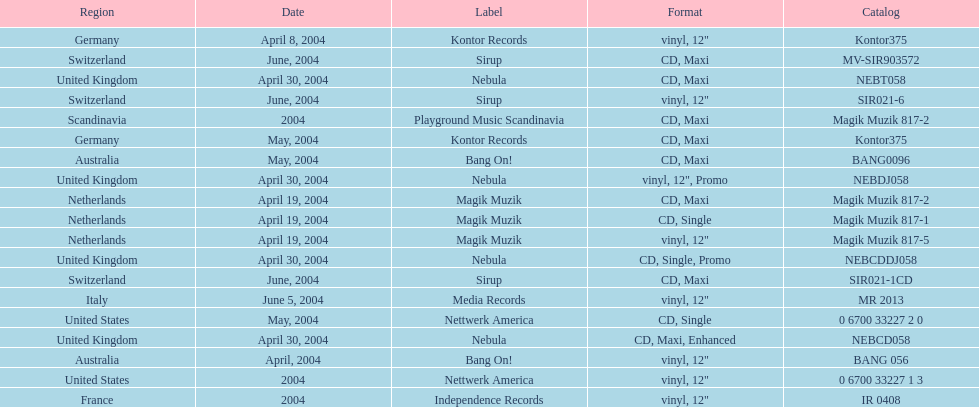What region is listed at the top? Netherlands. 